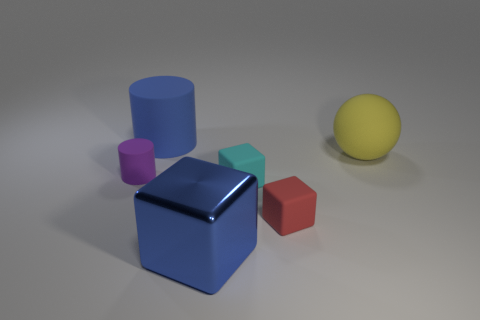There is a red rubber thing behind the blue block; what is its shape?
Offer a very short reply. Cube. What is the color of the metal object?
Keep it short and to the point. Blue. What is the color of the tiny cylinder that is made of the same material as the large blue cylinder?
Offer a terse response. Purple. What number of blue spheres have the same material as the large cylinder?
Offer a very short reply. 0. How many small cyan rubber things are behind the large sphere?
Make the answer very short. 0. Does the cylinder that is in front of the blue cylinder have the same material as the large blue thing in front of the yellow sphere?
Keep it short and to the point. No. Are there more large objects that are on the right side of the tiny cyan thing than red cubes to the right of the large yellow matte sphere?
Offer a very short reply. Yes. There is a cube that is the same color as the large matte cylinder; what is its material?
Give a very brief answer. Metal. Is there any other thing that is the same shape as the yellow matte thing?
Your response must be concise. No. There is a thing that is both behind the cyan rubber object and to the right of the large blue cylinder; what is it made of?
Give a very brief answer. Rubber. 